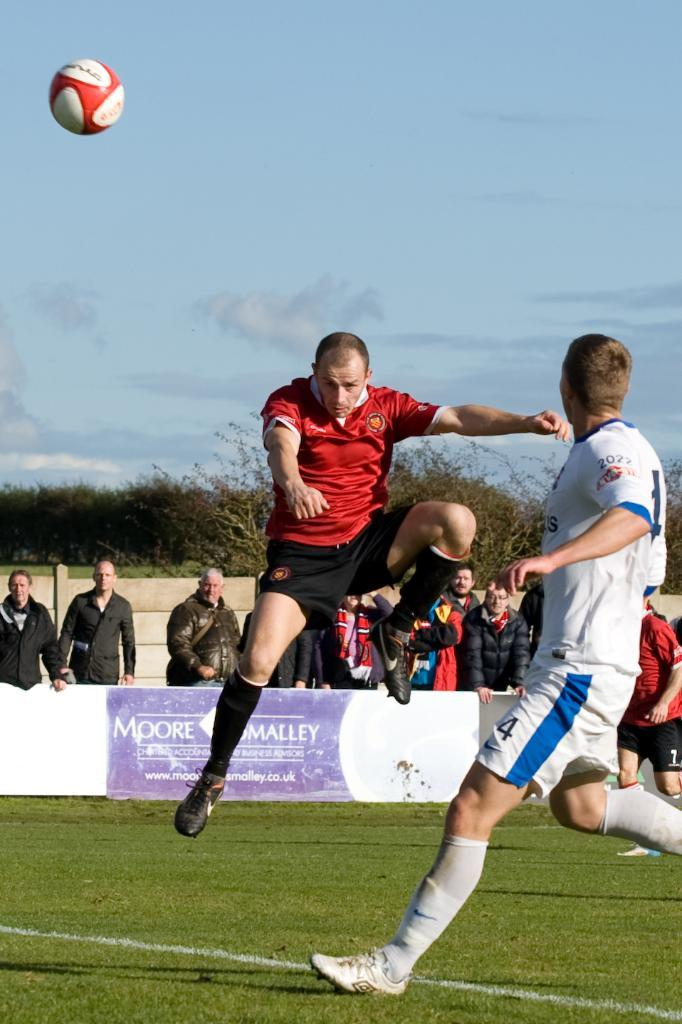<image>
Render a clear and concise summary of the photo. A soccer team is competing for the ball and a player in white has the number 2022 on his sleeve. 